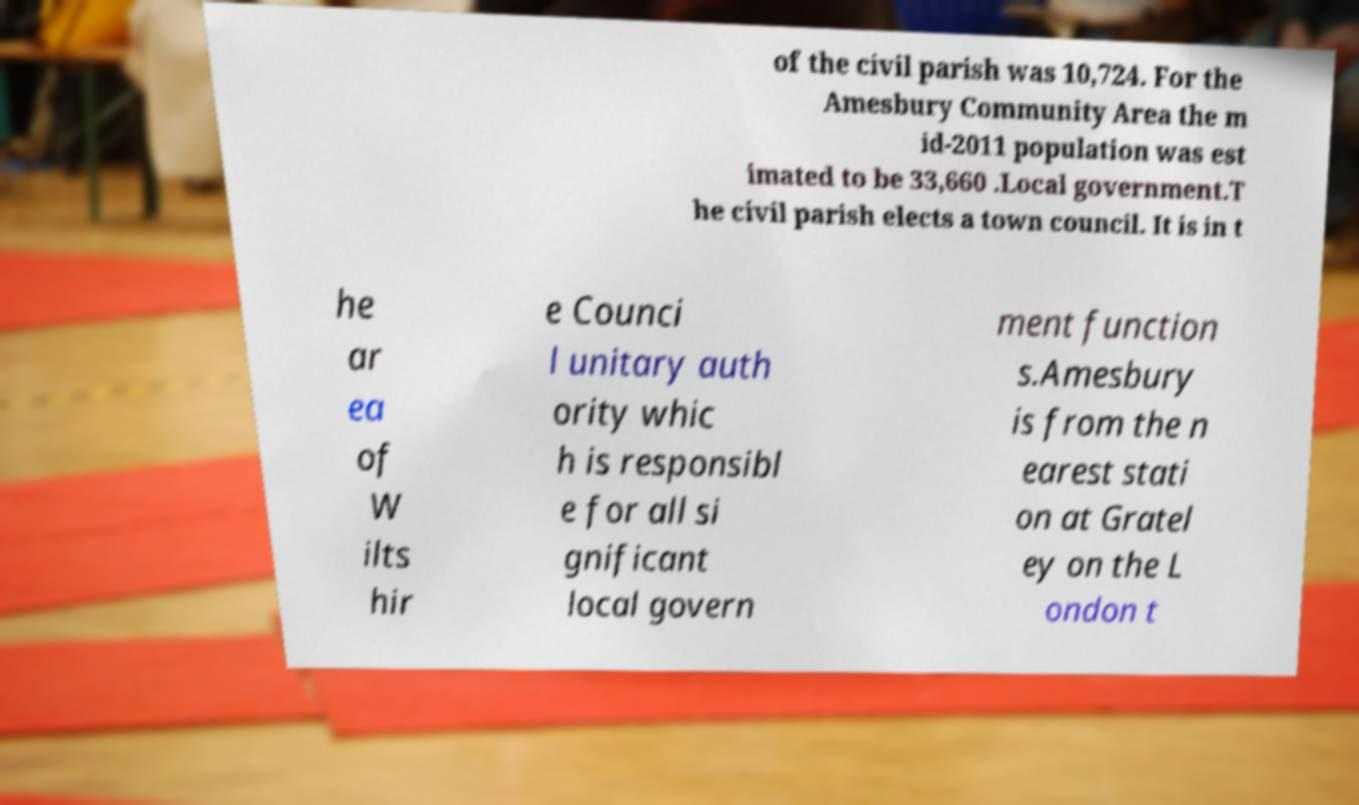Could you extract and type out the text from this image? of the civil parish was 10,724. For the Amesbury Community Area the m id-2011 population was est imated to be 33,660 .Local government.T he civil parish elects a town council. It is in t he ar ea of W ilts hir e Counci l unitary auth ority whic h is responsibl e for all si gnificant local govern ment function s.Amesbury is from the n earest stati on at Gratel ey on the L ondon t 